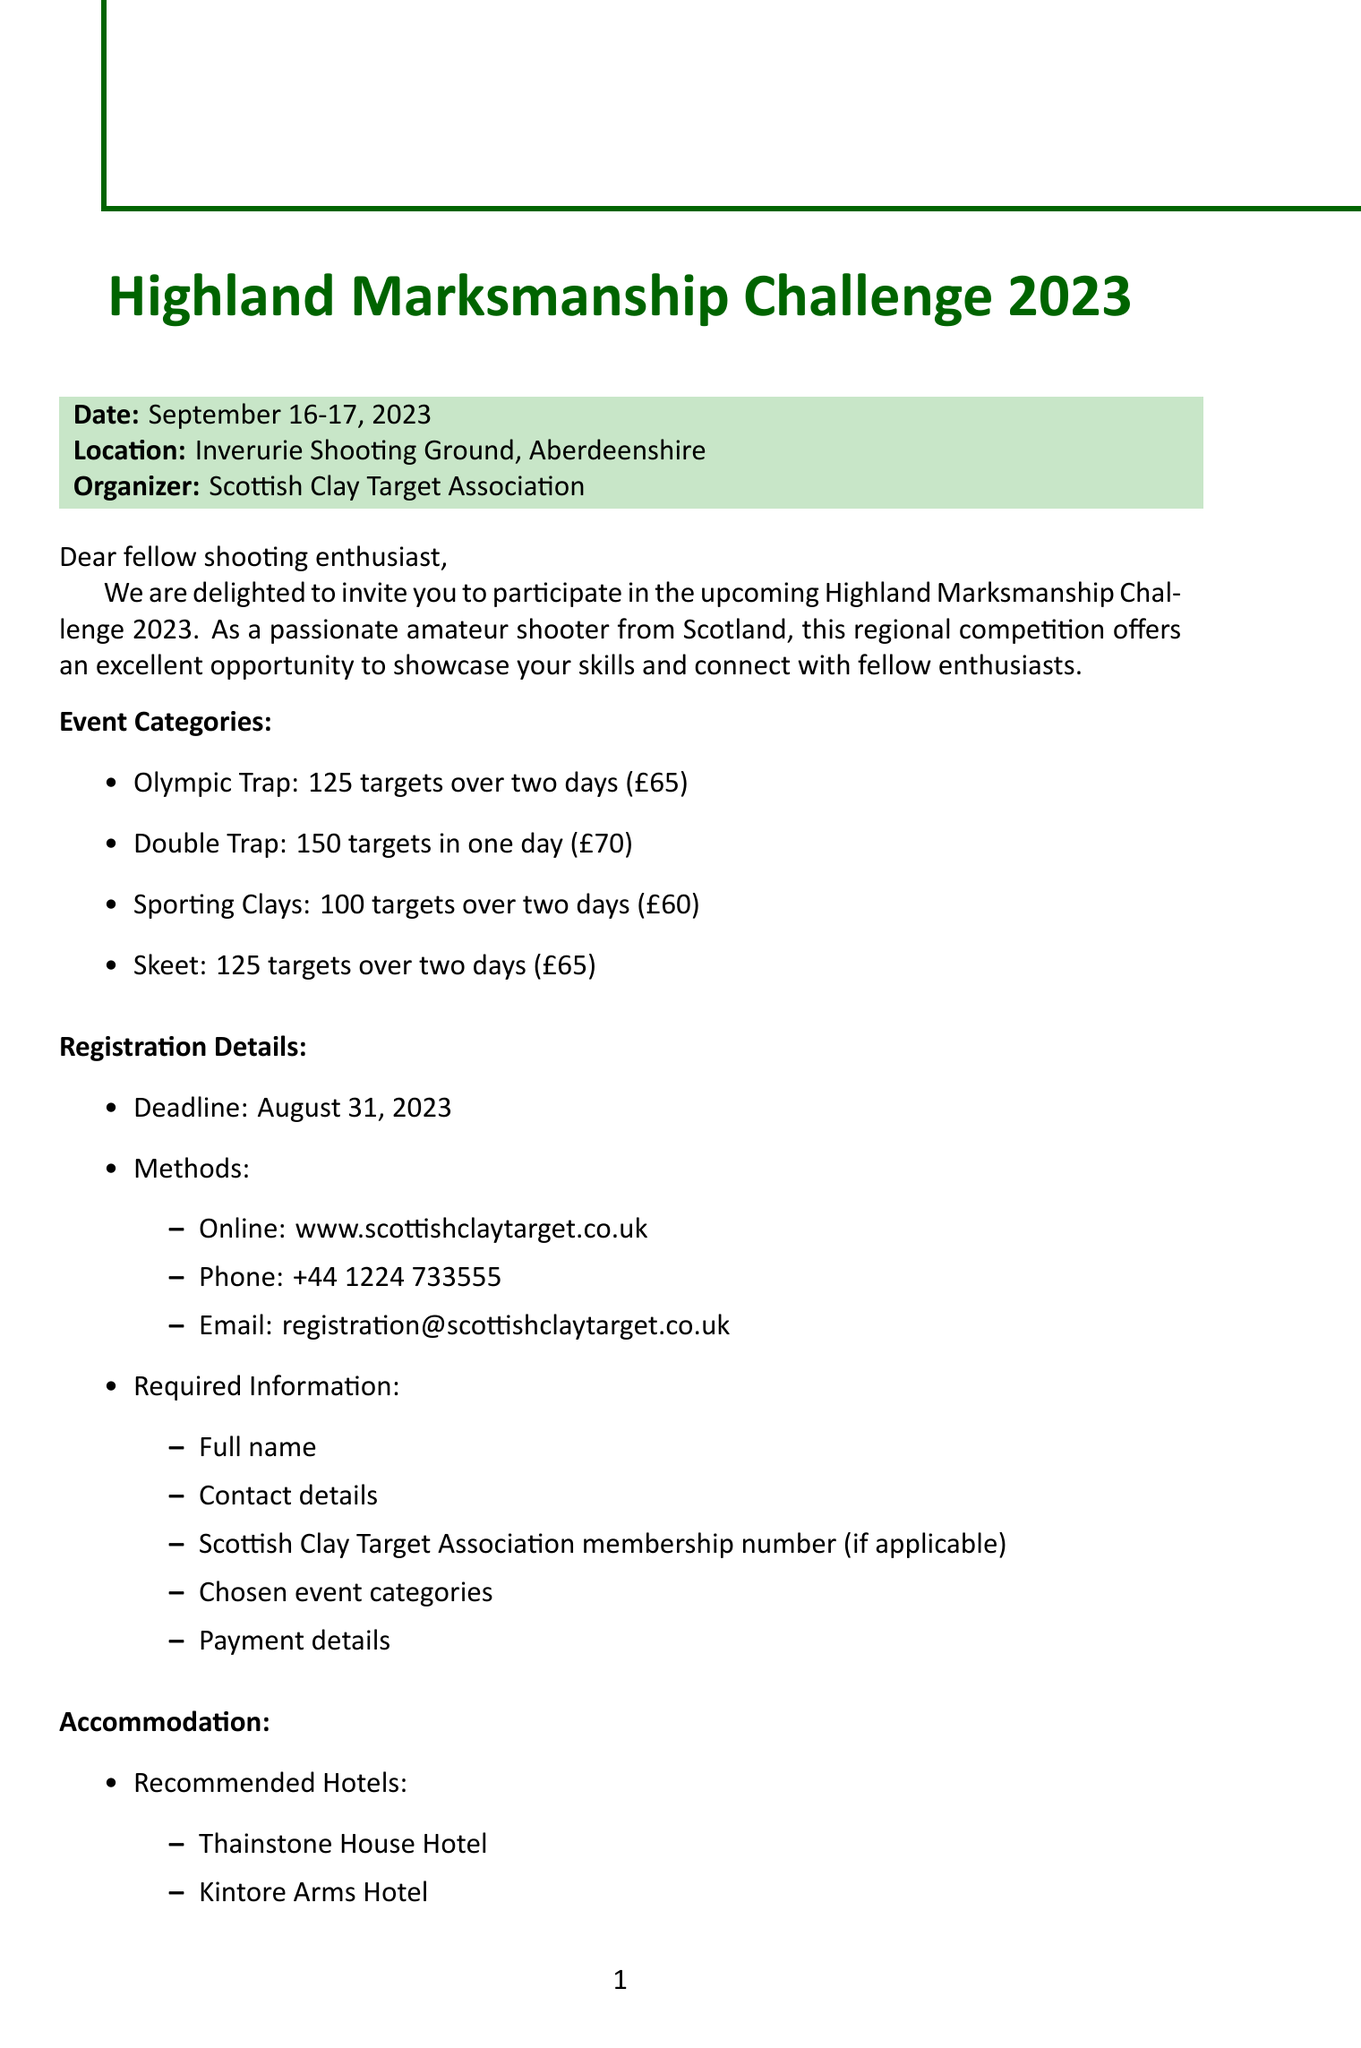What is the event name? The event name is clearly stated at the beginning of the document.
Answer: Highland Marksmanship Challenge 2023 Where is the competition taking place? The location of the event is mentioned in the document right after the event name.
Answer: Inverurie Shooting Ground, Aberdeenshire What is the registration deadline? The registration deadline is specified in the registration details section of the document.
Answer: August 31, 2023 How many targets are there in the Double Trap category? The Double Trap category details provide the total number of targets during the event.
Answer: 150 targets in one day What is the entry fee for Sporting Clays? The entry fee for Sporting Clays is provided in the event categories section.
Answer: £60 What type of food will be available during the event? The catering section mentions the availability of food and refreshments at the event.
Answer: Food and refreshments What is the prize for top performers? The additional information section discusses prizes in the competition.
Answer: Trophies and cash prizes Who is the contact person for the event? The contact person's information is given at the end of the document under the contact details.
Answer: Angus MacLeod How much is on-site camping per night? The accommodation section mentions the cost for on-site camping.
Answer: £15 per night What is included in the social event on Saturday? The additional information section describes the details of the social event planned for Saturday evening.
Answer: Ceilidh and dinner at Thainstone House Hotel 